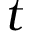<formula> <loc_0><loc_0><loc_500><loc_500>t</formula> 